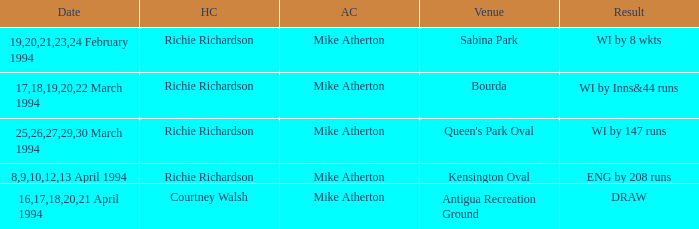What is the Venue which has a Wi by 8 wkts? Sabina Park. 